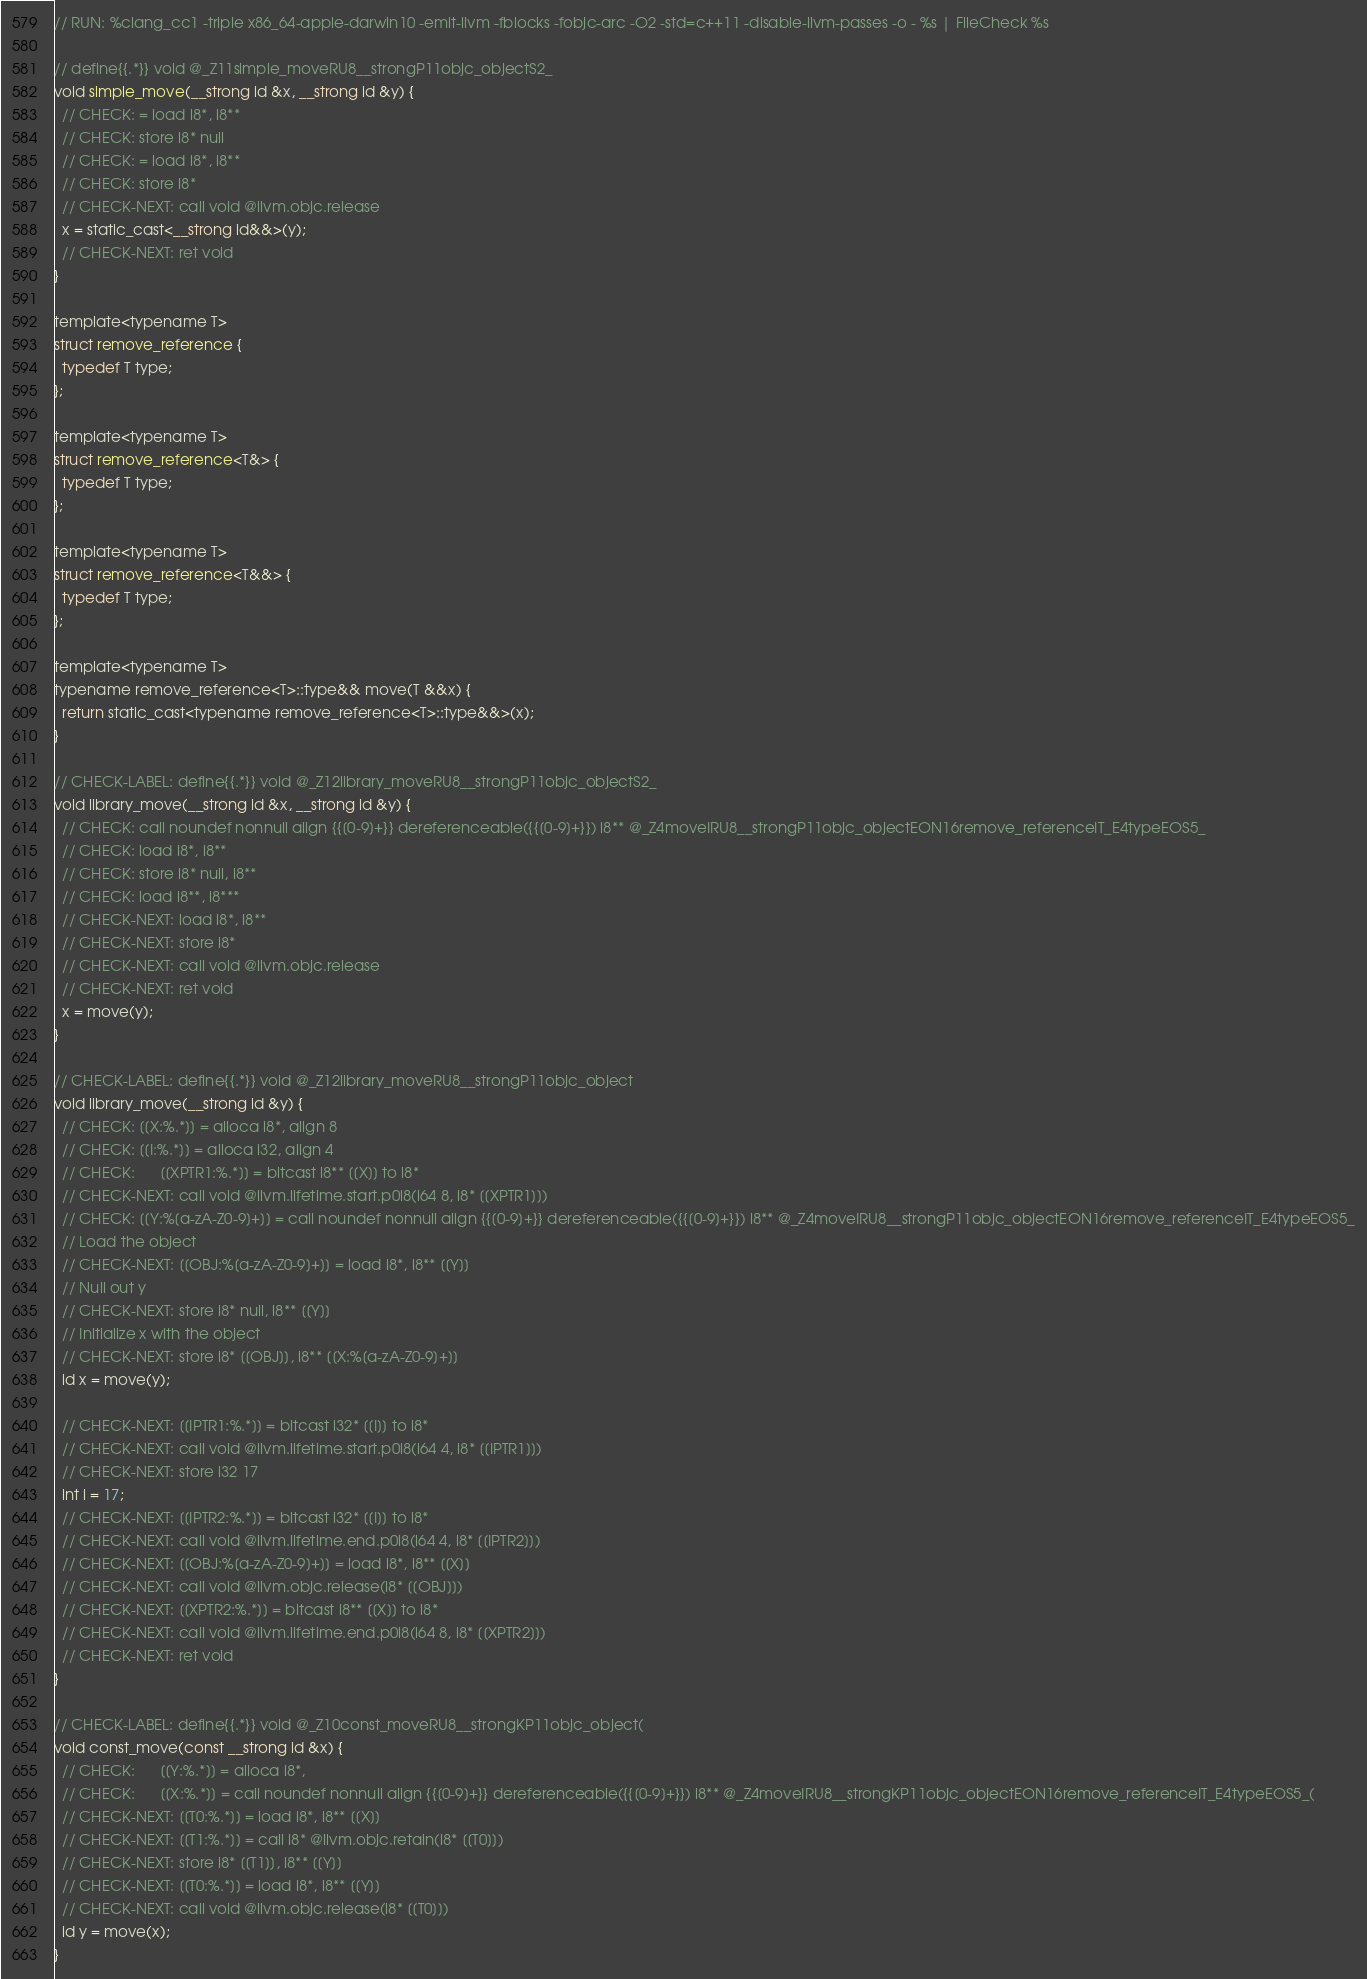Convert code to text. <code><loc_0><loc_0><loc_500><loc_500><_ObjectiveC_>// RUN: %clang_cc1 -triple x86_64-apple-darwin10 -emit-llvm -fblocks -fobjc-arc -O2 -std=c++11 -disable-llvm-passes -o - %s | FileCheck %s

// define{{.*}} void @_Z11simple_moveRU8__strongP11objc_objectS2_
void simple_move(__strong id &x, __strong id &y) {
  // CHECK: = load i8*, i8**
  // CHECK: store i8* null
  // CHECK: = load i8*, i8**
  // CHECK: store i8*
  // CHECK-NEXT: call void @llvm.objc.release
  x = static_cast<__strong id&&>(y);
  // CHECK-NEXT: ret void
}

template<typename T>
struct remove_reference {
  typedef T type;
};

template<typename T>
struct remove_reference<T&> {
  typedef T type;
};

template<typename T>
struct remove_reference<T&&> {
  typedef T type;
};

template<typename T> 
typename remove_reference<T>::type&& move(T &&x) { 
  return static_cast<typename remove_reference<T>::type&&>(x); 
}

// CHECK-LABEL: define{{.*}} void @_Z12library_moveRU8__strongP11objc_objectS2_
void library_move(__strong id &x, __strong id &y) {
  // CHECK: call noundef nonnull align {{[0-9]+}} dereferenceable({{[0-9]+}}) i8** @_Z4moveIRU8__strongP11objc_objectEON16remove_referenceIT_E4typeEOS5_
  // CHECK: load i8*, i8**
  // CHECK: store i8* null, i8**
  // CHECK: load i8**, i8***
  // CHECK-NEXT: load i8*, i8**
  // CHECK-NEXT: store i8*
  // CHECK-NEXT: call void @llvm.objc.release
  // CHECK-NEXT: ret void
  x = move(y);
}

// CHECK-LABEL: define{{.*}} void @_Z12library_moveRU8__strongP11objc_object
void library_move(__strong id &y) {
  // CHECK: [[X:%.*]] = alloca i8*, align 8
  // CHECK: [[I:%.*]] = alloca i32, align 4
  // CHECK:      [[XPTR1:%.*]] = bitcast i8** [[X]] to i8*
  // CHECK-NEXT: call void @llvm.lifetime.start.p0i8(i64 8, i8* [[XPTR1]])
  // CHECK: [[Y:%[a-zA-Z0-9]+]] = call noundef nonnull align {{[0-9]+}} dereferenceable({{[0-9]+}}) i8** @_Z4moveIRU8__strongP11objc_objectEON16remove_referenceIT_E4typeEOS5_
  // Load the object
  // CHECK-NEXT: [[OBJ:%[a-zA-Z0-9]+]] = load i8*, i8** [[Y]]
  // Null out y
  // CHECK-NEXT: store i8* null, i8** [[Y]]
  // Initialize x with the object
  // CHECK-NEXT: store i8* [[OBJ]], i8** [[X:%[a-zA-Z0-9]+]]
  id x = move(y);

  // CHECK-NEXT: [[IPTR1:%.*]] = bitcast i32* [[I]] to i8*
  // CHECK-NEXT: call void @llvm.lifetime.start.p0i8(i64 4, i8* [[IPTR1]])
  // CHECK-NEXT: store i32 17
  int i = 17;
  // CHECK-NEXT: [[IPTR2:%.*]] = bitcast i32* [[I]] to i8*
  // CHECK-NEXT: call void @llvm.lifetime.end.p0i8(i64 4, i8* [[IPTR2]])
  // CHECK-NEXT: [[OBJ:%[a-zA-Z0-9]+]] = load i8*, i8** [[X]]
  // CHECK-NEXT: call void @llvm.objc.release(i8* [[OBJ]])
  // CHECK-NEXT: [[XPTR2:%.*]] = bitcast i8** [[X]] to i8*
  // CHECK-NEXT: call void @llvm.lifetime.end.p0i8(i64 8, i8* [[XPTR2]])
  // CHECK-NEXT: ret void
}

// CHECK-LABEL: define{{.*}} void @_Z10const_moveRU8__strongKP11objc_object(
void const_move(const __strong id &x) {
  // CHECK:      [[Y:%.*]] = alloca i8*,
  // CHECK:      [[X:%.*]] = call noundef nonnull align {{[0-9]+}} dereferenceable({{[0-9]+}}) i8** @_Z4moveIRU8__strongKP11objc_objectEON16remove_referenceIT_E4typeEOS5_(
  // CHECK-NEXT: [[T0:%.*]] = load i8*, i8** [[X]]
  // CHECK-NEXT: [[T1:%.*]] = call i8* @llvm.objc.retain(i8* [[T0]])
  // CHECK-NEXT: store i8* [[T1]], i8** [[Y]]
  // CHECK-NEXT: [[T0:%.*]] = load i8*, i8** [[Y]]
  // CHECK-NEXT: call void @llvm.objc.release(i8* [[T0]])
  id y = move(x);
}
</code> 